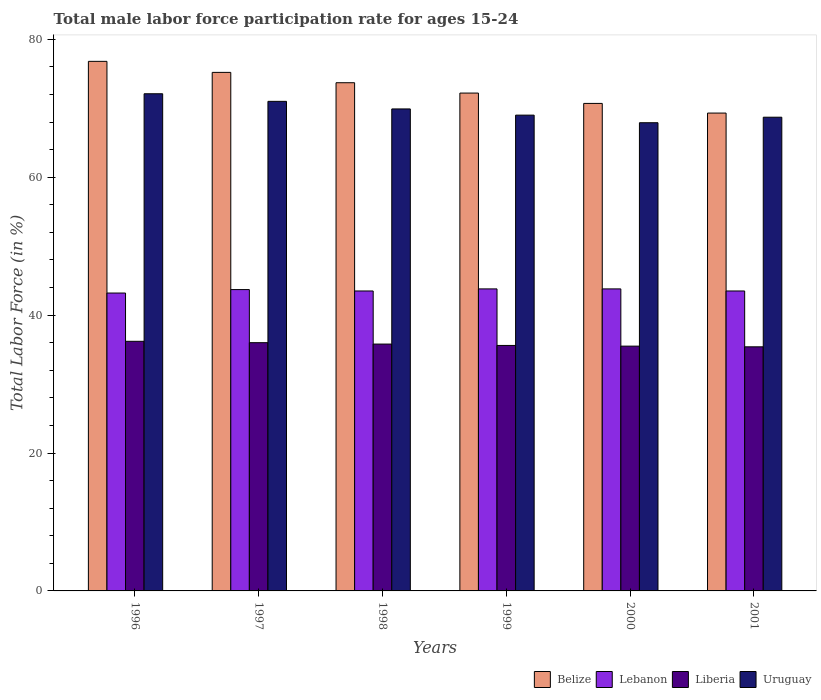How many different coloured bars are there?
Your response must be concise. 4. How many groups of bars are there?
Offer a terse response. 6. Are the number of bars per tick equal to the number of legend labels?
Make the answer very short. Yes. How many bars are there on the 4th tick from the left?
Keep it short and to the point. 4. What is the male labor force participation rate in Lebanon in 2000?
Your answer should be very brief. 43.8. Across all years, what is the maximum male labor force participation rate in Uruguay?
Your response must be concise. 72.1. Across all years, what is the minimum male labor force participation rate in Lebanon?
Give a very brief answer. 43.2. What is the total male labor force participation rate in Lebanon in the graph?
Give a very brief answer. 261.5. What is the difference between the male labor force participation rate in Belize in 1999 and that in 2001?
Ensure brevity in your answer.  2.9. What is the difference between the male labor force participation rate in Belize in 1998 and the male labor force participation rate in Uruguay in 1999?
Your answer should be very brief. 4.7. What is the average male labor force participation rate in Lebanon per year?
Make the answer very short. 43.58. In the year 2001, what is the difference between the male labor force participation rate in Lebanon and male labor force participation rate in Liberia?
Offer a very short reply. 8.1. In how many years, is the male labor force participation rate in Belize greater than 24 %?
Your response must be concise. 6. What is the difference between the highest and the second highest male labor force participation rate in Liberia?
Your answer should be compact. 0.2. In how many years, is the male labor force participation rate in Liberia greater than the average male labor force participation rate in Liberia taken over all years?
Make the answer very short. 3. What does the 3rd bar from the left in 1998 represents?
Make the answer very short. Liberia. What does the 1st bar from the right in 1997 represents?
Your response must be concise. Uruguay. Are all the bars in the graph horizontal?
Provide a succinct answer. No. Does the graph contain any zero values?
Make the answer very short. No. Where does the legend appear in the graph?
Provide a succinct answer. Bottom right. How are the legend labels stacked?
Make the answer very short. Horizontal. What is the title of the graph?
Offer a terse response. Total male labor force participation rate for ages 15-24. Does "Luxembourg" appear as one of the legend labels in the graph?
Your answer should be very brief. No. What is the label or title of the Y-axis?
Keep it short and to the point. Total Labor Force (in %). What is the Total Labor Force (in %) in Belize in 1996?
Your answer should be very brief. 76.8. What is the Total Labor Force (in %) in Lebanon in 1996?
Offer a terse response. 43.2. What is the Total Labor Force (in %) in Liberia in 1996?
Your answer should be compact. 36.2. What is the Total Labor Force (in %) in Uruguay in 1996?
Offer a very short reply. 72.1. What is the Total Labor Force (in %) of Belize in 1997?
Offer a terse response. 75.2. What is the Total Labor Force (in %) in Lebanon in 1997?
Provide a short and direct response. 43.7. What is the Total Labor Force (in %) of Uruguay in 1997?
Make the answer very short. 71. What is the Total Labor Force (in %) in Belize in 1998?
Make the answer very short. 73.7. What is the Total Labor Force (in %) of Lebanon in 1998?
Give a very brief answer. 43.5. What is the Total Labor Force (in %) of Liberia in 1998?
Make the answer very short. 35.8. What is the Total Labor Force (in %) in Uruguay in 1998?
Your answer should be very brief. 69.9. What is the Total Labor Force (in %) of Belize in 1999?
Your answer should be very brief. 72.2. What is the Total Labor Force (in %) of Lebanon in 1999?
Keep it short and to the point. 43.8. What is the Total Labor Force (in %) of Liberia in 1999?
Give a very brief answer. 35.6. What is the Total Labor Force (in %) of Belize in 2000?
Make the answer very short. 70.7. What is the Total Labor Force (in %) of Lebanon in 2000?
Provide a short and direct response. 43.8. What is the Total Labor Force (in %) of Liberia in 2000?
Provide a succinct answer. 35.5. What is the Total Labor Force (in %) in Uruguay in 2000?
Your response must be concise. 67.9. What is the Total Labor Force (in %) in Belize in 2001?
Offer a very short reply. 69.3. What is the Total Labor Force (in %) in Lebanon in 2001?
Offer a terse response. 43.5. What is the Total Labor Force (in %) of Liberia in 2001?
Your response must be concise. 35.4. What is the Total Labor Force (in %) of Uruguay in 2001?
Your answer should be compact. 68.7. Across all years, what is the maximum Total Labor Force (in %) of Belize?
Make the answer very short. 76.8. Across all years, what is the maximum Total Labor Force (in %) of Lebanon?
Your answer should be compact. 43.8. Across all years, what is the maximum Total Labor Force (in %) of Liberia?
Ensure brevity in your answer.  36.2. Across all years, what is the maximum Total Labor Force (in %) of Uruguay?
Your answer should be compact. 72.1. Across all years, what is the minimum Total Labor Force (in %) in Belize?
Offer a very short reply. 69.3. Across all years, what is the minimum Total Labor Force (in %) of Lebanon?
Ensure brevity in your answer.  43.2. Across all years, what is the minimum Total Labor Force (in %) of Liberia?
Keep it short and to the point. 35.4. Across all years, what is the minimum Total Labor Force (in %) in Uruguay?
Offer a very short reply. 67.9. What is the total Total Labor Force (in %) of Belize in the graph?
Offer a terse response. 437.9. What is the total Total Labor Force (in %) in Lebanon in the graph?
Provide a short and direct response. 261.5. What is the total Total Labor Force (in %) of Liberia in the graph?
Keep it short and to the point. 214.5. What is the total Total Labor Force (in %) of Uruguay in the graph?
Provide a succinct answer. 418.6. What is the difference between the Total Labor Force (in %) of Lebanon in 1996 and that in 1997?
Provide a succinct answer. -0.5. What is the difference between the Total Labor Force (in %) of Liberia in 1996 and that in 1997?
Keep it short and to the point. 0.2. What is the difference between the Total Labor Force (in %) in Uruguay in 1996 and that in 1998?
Offer a very short reply. 2.2. What is the difference between the Total Labor Force (in %) in Uruguay in 1996 and that in 1999?
Ensure brevity in your answer.  3.1. What is the difference between the Total Labor Force (in %) in Belize in 1996 and that in 2000?
Give a very brief answer. 6.1. What is the difference between the Total Labor Force (in %) in Lebanon in 1996 and that in 2000?
Your response must be concise. -0.6. What is the difference between the Total Labor Force (in %) in Liberia in 1996 and that in 2000?
Make the answer very short. 0.7. What is the difference between the Total Labor Force (in %) of Lebanon in 1996 and that in 2001?
Provide a short and direct response. -0.3. What is the difference between the Total Labor Force (in %) of Liberia in 1996 and that in 2001?
Your answer should be very brief. 0.8. What is the difference between the Total Labor Force (in %) in Liberia in 1997 and that in 1998?
Make the answer very short. 0.2. What is the difference between the Total Labor Force (in %) of Uruguay in 1997 and that in 1998?
Your answer should be compact. 1.1. What is the difference between the Total Labor Force (in %) of Lebanon in 1997 and that in 1999?
Give a very brief answer. -0.1. What is the difference between the Total Labor Force (in %) of Uruguay in 1997 and that in 1999?
Your answer should be compact. 2. What is the difference between the Total Labor Force (in %) of Belize in 1997 and that in 2000?
Offer a terse response. 4.5. What is the difference between the Total Labor Force (in %) in Liberia in 1997 and that in 2000?
Your response must be concise. 0.5. What is the difference between the Total Labor Force (in %) in Uruguay in 1997 and that in 2000?
Make the answer very short. 3.1. What is the difference between the Total Labor Force (in %) in Liberia in 1998 and that in 1999?
Provide a short and direct response. 0.2. What is the difference between the Total Labor Force (in %) of Uruguay in 1998 and that in 1999?
Your answer should be compact. 0.9. What is the difference between the Total Labor Force (in %) of Liberia in 1998 and that in 2000?
Your answer should be compact. 0.3. What is the difference between the Total Labor Force (in %) in Uruguay in 1998 and that in 2000?
Ensure brevity in your answer.  2. What is the difference between the Total Labor Force (in %) in Lebanon in 1998 and that in 2001?
Provide a short and direct response. 0. What is the difference between the Total Labor Force (in %) in Liberia in 1998 and that in 2001?
Provide a succinct answer. 0.4. What is the difference between the Total Labor Force (in %) in Uruguay in 1998 and that in 2001?
Provide a succinct answer. 1.2. What is the difference between the Total Labor Force (in %) in Belize in 1999 and that in 2000?
Your answer should be compact. 1.5. What is the difference between the Total Labor Force (in %) in Liberia in 1999 and that in 2000?
Your answer should be very brief. 0.1. What is the difference between the Total Labor Force (in %) of Lebanon in 1999 and that in 2001?
Make the answer very short. 0.3. What is the difference between the Total Labor Force (in %) in Liberia in 1999 and that in 2001?
Provide a short and direct response. 0.2. What is the difference between the Total Labor Force (in %) of Belize in 2000 and that in 2001?
Provide a short and direct response. 1.4. What is the difference between the Total Labor Force (in %) in Uruguay in 2000 and that in 2001?
Ensure brevity in your answer.  -0.8. What is the difference between the Total Labor Force (in %) of Belize in 1996 and the Total Labor Force (in %) of Lebanon in 1997?
Your answer should be very brief. 33.1. What is the difference between the Total Labor Force (in %) in Belize in 1996 and the Total Labor Force (in %) in Liberia in 1997?
Offer a terse response. 40.8. What is the difference between the Total Labor Force (in %) in Belize in 1996 and the Total Labor Force (in %) in Uruguay in 1997?
Provide a short and direct response. 5.8. What is the difference between the Total Labor Force (in %) of Lebanon in 1996 and the Total Labor Force (in %) of Liberia in 1997?
Provide a short and direct response. 7.2. What is the difference between the Total Labor Force (in %) of Lebanon in 1996 and the Total Labor Force (in %) of Uruguay in 1997?
Give a very brief answer. -27.8. What is the difference between the Total Labor Force (in %) of Liberia in 1996 and the Total Labor Force (in %) of Uruguay in 1997?
Provide a succinct answer. -34.8. What is the difference between the Total Labor Force (in %) of Belize in 1996 and the Total Labor Force (in %) of Lebanon in 1998?
Offer a very short reply. 33.3. What is the difference between the Total Labor Force (in %) in Belize in 1996 and the Total Labor Force (in %) in Liberia in 1998?
Keep it short and to the point. 41. What is the difference between the Total Labor Force (in %) in Belize in 1996 and the Total Labor Force (in %) in Uruguay in 1998?
Provide a succinct answer. 6.9. What is the difference between the Total Labor Force (in %) in Lebanon in 1996 and the Total Labor Force (in %) in Liberia in 1998?
Your response must be concise. 7.4. What is the difference between the Total Labor Force (in %) in Lebanon in 1996 and the Total Labor Force (in %) in Uruguay in 1998?
Your response must be concise. -26.7. What is the difference between the Total Labor Force (in %) of Liberia in 1996 and the Total Labor Force (in %) of Uruguay in 1998?
Keep it short and to the point. -33.7. What is the difference between the Total Labor Force (in %) of Belize in 1996 and the Total Labor Force (in %) of Lebanon in 1999?
Provide a succinct answer. 33. What is the difference between the Total Labor Force (in %) of Belize in 1996 and the Total Labor Force (in %) of Liberia in 1999?
Your response must be concise. 41.2. What is the difference between the Total Labor Force (in %) in Belize in 1996 and the Total Labor Force (in %) in Uruguay in 1999?
Your answer should be very brief. 7.8. What is the difference between the Total Labor Force (in %) in Lebanon in 1996 and the Total Labor Force (in %) in Uruguay in 1999?
Your response must be concise. -25.8. What is the difference between the Total Labor Force (in %) of Liberia in 1996 and the Total Labor Force (in %) of Uruguay in 1999?
Make the answer very short. -32.8. What is the difference between the Total Labor Force (in %) in Belize in 1996 and the Total Labor Force (in %) in Lebanon in 2000?
Ensure brevity in your answer.  33. What is the difference between the Total Labor Force (in %) of Belize in 1996 and the Total Labor Force (in %) of Liberia in 2000?
Keep it short and to the point. 41.3. What is the difference between the Total Labor Force (in %) of Lebanon in 1996 and the Total Labor Force (in %) of Uruguay in 2000?
Provide a short and direct response. -24.7. What is the difference between the Total Labor Force (in %) of Liberia in 1996 and the Total Labor Force (in %) of Uruguay in 2000?
Provide a succinct answer. -31.7. What is the difference between the Total Labor Force (in %) in Belize in 1996 and the Total Labor Force (in %) in Lebanon in 2001?
Provide a succinct answer. 33.3. What is the difference between the Total Labor Force (in %) in Belize in 1996 and the Total Labor Force (in %) in Liberia in 2001?
Provide a short and direct response. 41.4. What is the difference between the Total Labor Force (in %) in Lebanon in 1996 and the Total Labor Force (in %) in Uruguay in 2001?
Offer a terse response. -25.5. What is the difference between the Total Labor Force (in %) in Liberia in 1996 and the Total Labor Force (in %) in Uruguay in 2001?
Provide a succinct answer. -32.5. What is the difference between the Total Labor Force (in %) of Belize in 1997 and the Total Labor Force (in %) of Lebanon in 1998?
Ensure brevity in your answer.  31.7. What is the difference between the Total Labor Force (in %) of Belize in 1997 and the Total Labor Force (in %) of Liberia in 1998?
Make the answer very short. 39.4. What is the difference between the Total Labor Force (in %) in Lebanon in 1997 and the Total Labor Force (in %) in Uruguay in 1998?
Your answer should be very brief. -26.2. What is the difference between the Total Labor Force (in %) in Liberia in 1997 and the Total Labor Force (in %) in Uruguay in 1998?
Offer a terse response. -33.9. What is the difference between the Total Labor Force (in %) of Belize in 1997 and the Total Labor Force (in %) of Lebanon in 1999?
Make the answer very short. 31.4. What is the difference between the Total Labor Force (in %) of Belize in 1997 and the Total Labor Force (in %) of Liberia in 1999?
Offer a terse response. 39.6. What is the difference between the Total Labor Force (in %) in Belize in 1997 and the Total Labor Force (in %) in Uruguay in 1999?
Ensure brevity in your answer.  6.2. What is the difference between the Total Labor Force (in %) of Lebanon in 1997 and the Total Labor Force (in %) of Uruguay in 1999?
Provide a succinct answer. -25.3. What is the difference between the Total Labor Force (in %) of Liberia in 1997 and the Total Labor Force (in %) of Uruguay in 1999?
Provide a short and direct response. -33. What is the difference between the Total Labor Force (in %) of Belize in 1997 and the Total Labor Force (in %) of Lebanon in 2000?
Give a very brief answer. 31.4. What is the difference between the Total Labor Force (in %) in Belize in 1997 and the Total Labor Force (in %) in Liberia in 2000?
Make the answer very short. 39.7. What is the difference between the Total Labor Force (in %) in Belize in 1997 and the Total Labor Force (in %) in Uruguay in 2000?
Your response must be concise. 7.3. What is the difference between the Total Labor Force (in %) in Lebanon in 1997 and the Total Labor Force (in %) in Uruguay in 2000?
Ensure brevity in your answer.  -24.2. What is the difference between the Total Labor Force (in %) in Liberia in 1997 and the Total Labor Force (in %) in Uruguay in 2000?
Provide a succinct answer. -31.9. What is the difference between the Total Labor Force (in %) in Belize in 1997 and the Total Labor Force (in %) in Lebanon in 2001?
Provide a succinct answer. 31.7. What is the difference between the Total Labor Force (in %) in Belize in 1997 and the Total Labor Force (in %) in Liberia in 2001?
Provide a succinct answer. 39.8. What is the difference between the Total Labor Force (in %) in Belize in 1997 and the Total Labor Force (in %) in Uruguay in 2001?
Give a very brief answer. 6.5. What is the difference between the Total Labor Force (in %) in Lebanon in 1997 and the Total Labor Force (in %) in Liberia in 2001?
Your answer should be compact. 8.3. What is the difference between the Total Labor Force (in %) in Lebanon in 1997 and the Total Labor Force (in %) in Uruguay in 2001?
Keep it short and to the point. -25. What is the difference between the Total Labor Force (in %) in Liberia in 1997 and the Total Labor Force (in %) in Uruguay in 2001?
Offer a terse response. -32.7. What is the difference between the Total Labor Force (in %) in Belize in 1998 and the Total Labor Force (in %) in Lebanon in 1999?
Ensure brevity in your answer.  29.9. What is the difference between the Total Labor Force (in %) in Belize in 1998 and the Total Labor Force (in %) in Liberia in 1999?
Make the answer very short. 38.1. What is the difference between the Total Labor Force (in %) in Lebanon in 1998 and the Total Labor Force (in %) in Uruguay in 1999?
Give a very brief answer. -25.5. What is the difference between the Total Labor Force (in %) of Liberia in 1998 and the Total Labor Force (in %) of Uruguay in 1999?
Your response must be concise. -33.2. What is the difference between the Total Labor Force (in %) in Belize in 1998 and the Total Labor Force (in %) in Lebanon in 2000?
Give a very brief answer. 29.9. What is the difference between the Total Labor Force (in %) of Belize in 1998 and the Total Labor Force (in %) of Liberia in 2000?
Make the answer very short. 38.2. What is the difference between the Total Labor Force (in %) of Lebanon in 1998 and the Total Labor Force (in %) of Liberia in 2000?
Ensure brevity in your answer.  8. What is the difference between the Total Labor Force (in %) in Lebanon in 1998 and the Total Labor Force (in %) in Uruguay in 2000?
Provide a succinct answer. -24.4. What is the difference between the Total Labor Force (in %) in Liberia in 1998 and the Total Labor Force (in %) in Uruguay in 2000?
Your answer should be compact. -32.1. What is the difference between the Total Labor Force (in %) of Belize in 1998 and the Total Labor Force (in %) of Lebanon in 2001?
Your answer should be very brief. 30.2. What is the difference between the Total Labor Force (in %) in Belize in 1998 and the Total Labor Force (in %) in Liberia in 2001?
Offer a very short reply. 38.3. What is the difference between the Total Labor Force (in %) in Lebanon in 1998 and the Total Labor Force (in %) in Uruguay in 2001?
Provide a short and direct response. -25.2. What is the difference between the Total Labor Force (in %) in Liberia in 1998 and the Total Labor Force (in %) in Uruguay in 2001?
Offer a very short reply. -32.9. What is the difference between the Total Labor Force (in %) of Belize in 1999 and the Total Labor Force (in %) of Lebanon in 2000?
Ensure brevity in your answer.  28.4. What is the difference between the Total Labor Force (in %) of Belize in 1999 and the Total Labor Force (in %) of Liberia in 2000?
Give a very brief answer. 36.7. What is the difference between the Total Labor Force (in %) in Belize in 1999 and the Total Labor Force (in %) in Uruguay in 2000?
Your response must be concise. 4.3. What is the difference between the Total Labor Force (in %) of Lebanon in 1999 and the Total Labor Force (in %) of Uruguay in 2000?
Offer a very short reply. -24.1. What is the difference between the Total Labor Force (in %) of Liberia in 1999 and the Total Labor Force (in %) of Uruguay in 2000?
Make the answer very short. -32.3. What is the difference between the Total Labor Force (in %) of Belize in 1999 and the Total Labor Force (in %) of Lebanon in 2001?
Ensure brevity in your answer.  28.7. What is the difference between the Total Labor Force (in %) in Belize in 1999 and the Total Labor Force (in %) in Liberia in 2001?
Provide a succinct answer. 36.8. What is the difference between the Total Labor Force (in %) in Belize in 1999 and the Total Labor Force (in %) in Uruguay in 2001?
Ensure brevity in your answer.  3.5. What is the difference between the Total Labor Force (in %) of Lebanon in 1999 and the Total Labor Force (in %) of Liberia in 2001?
Offer a terse response. 8.4. What is the difference between the Total Labor Force (in %) of Lebanon in 1999 and the Total Labor Force (in %) of Uruguay in 2001?
Provide a succinct answer. -24.9. What is the difference between the Total Labor Force (in %) of Liberia in 1999 and the Total Labor Force (in %) of Uruguay in 2001?
Provide a short and direct response. -33.1. What is the difference between the Total Labor Force (in %) in Belize in 2000 and the Total Labor Force (in %) in Lebanon in 2001?
Give a very brief answer. 27.2. What is the difference between the Total Labor Force (in %) of Belize in 2000 and the Total Labor Force (in %) of Liberia in 2001?
Your answer should be compact. 35.3. What is the difference between the Total Labor Force (in %) of Belize in 2000 and the Total Labor Force (in %) of Uruguay in 2001?
Your response must be concise. 2. What is the difference between the Total Labor Force (in %) of Lebanon in 2000 and the Total Labor Force (in %) of Liberia in 2001?
Your answer should be very brief. 8.4. What is the difference between the Total Labor Force (in %) of Lebanon in 2000 and the Total Labor Force (in %) of Uruguay in 2001?
Keep it short and to the point. -24.9. What is the difference between the Total Labor Force (in %) of Liberia in 2000 and the Total Labor Force (in %) of Uruguay in 2001?
Offer a very short reply. -33.2. What is the average Total Labor Force (in %) of Belize per year?
Your response must be concise. 72.98. What is the average Total Labor Force (in %) of Lebanon per year?
Give a very brief answer. 43.58. What is the average Total Labor Force (in %) of Liberia per year?
Your response must be concise. 35.75. What is the average Total Labor Force (in %) of Uruguay per year?
Your response must be concise. 69.77. In the year 1996, what is the difference between the Total Labor Force (in %) of Belize and Total Labor Force (in %) of Lebanon?
Offer a very short reply. 33.6. In the year 1996, what is the difference between the Total Labor Force (in %) in Belize and Total Labor Force (in %) in Liberia?
Make the answer very short. 40.6. In the year 1996, what is the difference between the Total Labor Force (in %) of Belize and Total Labor Force (in %) of Uruguay?
Your answer should be compact. 4.7. In the year 1996, what is the difference between the Total Labor Force (in %) of Lebanon and Total Labor Force (in %) of Uruguay?
Offer a very short reply. -28.9. In the year 1996, what is the difference between the Total Labor Force (in %) in Liberia and Total Labor Force (in %) in Uruguay?
Make the answer very short. -35.9. In the year 1997, what is the difference between the Total Labor Force (in %) of Belize and Total Labor Force (in %) of Lebanon?
Provide a short and direct response. 31.5. In the year 1997, what is the difference between the Total Labor Force (in %) of Belize and Total Labor Force (in %) of Liberia?
Offer a very short reply. 39.2. In the year 1997, what is the difference between the Total Labor Force (in %) in Lebanon and Total Labor Force (in %) in Liberia?
Make the answer very short. 7.7. In the year 1997, what is the difference between the Total Labor Force (in %) of Lebanon and Total Labor Force (in %) of Uruguay?
Your response must be concise. -27.3. In the year 1997, what is the difference between the Total Labor Force (in %) in Liberia and Total Labor Force (in %) in Uruguay?
Give a very brief answer. -35. In the year 1998, what is the difference between the Total Labor Force (in %) of Belize and Total Labor Force (in %) of Lebanon?
Your response must be concise. 30.2. In the year 1998, what is the difference between the Total Labor Force (in %) in Belize and Total Labor Force (in %) in Liberia?
Give a very brief answer. 37.9. In the year 1998, what is the difference between the Total Labor Force (in %) in Lebanon and Total Labor Force (in %) in Liberia?
Your answer should be very brief. 7.7. In the year 1998, what is the difference between the Total Labor Force (in %) of Lebanon and Total Labor Force (in %) of Uruguay?
Keep it short and to the point. -26.4. In the year 1998, what is the difference between the Total Labor Force (in %) in Liberia and Total Labor Force (in %) in Uruguay?
Offer a very short reply. -34.1. In the year 1999, what is the difference between the Total Labor Force (in %) in Belize and Total Labor Force (in %) in Lebanon?
Your answer should be compact. 28.4. In the year 1999, what is the difference between the Total Labor Force (in %) in Belize and Total Labor Force (in %) in Liberia?
Your answer should be compact. 36.6. In the year 1999, what is the difference between the Total Labor Force (in %) of Belize and Total Labor Force (in %) of Uruguay?
Your answer should be very brief. 3.2. In the year 1999, what is the difference between the Total Labor Force (in %) in Lebanon and Total Labor Force (in %) in Liberia?
Your answer should be compact. 8.2. In the year 1999, what is the difference between the Total Labor Force (in %) of Lebanon and Total Labor Force (in %) of Uruguay?
Offer a terse response. -25.2. In the year 1999, what is the difference between the Total Labor Force (in %) of Liberia and Total Labor Force (in %) of Uruguay?
Your answer should be very brief. -33.4. In the year 2000, what is the difference between the Total Labor Force (in %) of Belize and Total Labor Force (in %) of Lebanon?
Your answer should be very brief. 26.9. In the year 2000, what is the difference between the Total Labor Force (in %) of Belize and Total Labor Force (in %) of Liberia?
Keep it short and to the point. 35.2. In the year 2000, what is the difference between the Total Labor Force (in %) in Lebanon and Total Labor Force (in %) in Uruguay?
Offer a very short reply. -24.1. In the year 2000, what is the difference between the Total Labor Force (in %) in Liberia and Total Labor Force (in %) in Uruguay?
Provide a short and direct response. -32.4. In the year 2001, what is the difference between the Total Labor Force (in %) in Belize and Total Labor Force (in %) in Lebanon?
Offer a terse response. 25.8. In the year 2001, what is the difference between the Total Labor Force (in %) in Belize and Total Labor Force (in %) in Liberia?
Your response must be concise. 33.9. In the year 2001, what is the difference between the Total Labor Force (in %) of Lebanon and Total Labor Force (in %) of Uruguay?
Your response must be concise. -25.2. In the year 2001, what is the difference between the Total Labor Force (in %) in Liberia and Total Labor Force (in %) in Uruguay?
Make the answer very short. -33.3. What is the ratio of the Total Labor Force (in %) in Belize in 1996 to that in 1997?
Offer a very short reply. 1.02. What is the ratio of the Total Labor Force (in %) of Lebanon in 1996 to that in 1997?
Ensure brevity in your answer.  0.99. What is the ratio of the Total Labor Force (in %) of Liberia in 1996 to that in 1997?
Your answer should be compact. 1.01. What is the ratio of the Total Labor Force (in %) in Uruguay in 1996 to that in 1997?
Ensure brevity in your answer.  1.02. What is the ratio of the Total Labor Force (in %) of Belize in 1996 to that in 1998?
Give a very brief answer. 1.04. What is the ratio of the Total Labor Force (in %) of Liberia in 1996 to that in 1998?
Provide a succinct answer. 1.01. What is the ratio of the Total Labor Force (in %) of Uruguay in 1996 to that in 1998?
Provide a short and direct response. 1.03. What is the ratio of the Total Labor Force (in %) in Belize in 1996 to that in 1999?
Offer a terse response. 1.06. What is the ratio of the Total Labor Force (in %) of Lebanon in 1996 to that in 1999?
Keep it short and to the point. 0.99. What is the ratio of the Total Labor Force (in %) of Liberia in 1996 to that in 1999?
Offer a terse response. 1.02. What is the ratio of the Total Labor Force (in %) in Uruguay in 1996 to that in 1999?
Give a very brief answer. 1.04. What is the ratio of the Total Labor Force (in %) in Belize in 1996 to that in 2000?
Your answer should be very brief. 1.09. What is the ratio of the Total Labor Force (in %) of Lebanon in 1996 to that in 2000?
Your response must be concise. 0.99. What is the ratio of the Total Labor Force (in %) in Liberia in 1996 to that in 2000?
Your answer should be very brief. 1.02. What is the ratio of the Total Labor Force (in %) in Uruguay in 1996 to that in 2000?
Your response must be concise. 1.06. What is the ratio of the Total Labor Force (in %) of Belize in 1996 to that in 2001?
Ensure brevity in your answer.  1.11. What is the ratio of the Total Labor Force (in %) of Liberia in 1996 to that in 2001?
Keep it short and to the point. 1.02. What is the ratio of the Total Labor Force (in %) in Uruguay in 1996 to that in 2001?
Your answer should be compact. 1.05. What is the ratio of the Total Labor Force (in %) of Belize in 1997 to that in 1998?
Ensure brevity in your answer.  1.02. What is the ratio of the Total Labor Force (in %) in Lebanon in 1997 to that in 1998?
Provide a succinct answer. 1. What is the ratio of the Total Labor Force (in %) of Liberia in 1997 to that in 1998?
Your answer should be very brief. 1.01. What is the ratio of the Total Labor Force (in %) in Uruguay in 1997 to that in 1998?
Give a very brief answer. 1.02. What is the ratio of the Total Labor Force (in %) of Belize in 1997 to that in 1999?
Offer a terse response. 1.04. What is the ratio of the Total Labor Force (in %) in Liberia in 1997 to that in 1999?
Your answer should be compact. 1.01. What is the ratio of the Total Labor Force (in %) in Uruguay in 1997 to that in 1999?
Offer a very short reply. 1.03. What is the ratio of the Total Labor Force (in %) in Belize in 1997 to that in 2000?
Keep it short and to the point. 1.06. What is the ratio of the Total Labor Force (in %) of Liberia in 1997 to that in 2000?
Your answer should be compact. 1.01. What is the ratio of the Total Labor Force (in %) in Uruguay in 1997 to that in 2000?
Provide a short and direct response. 1.05. What is the ratio of the Total Labor Force (in %) of Belize in 1997 to that in 2001?
Make the answer very short. 1.09. What is the ratio of the Total Labor Force (in %) in Liberia in 1997 to that in 2001?
Your response must be concise. 1.02. What is the ratio of the Total Labor Force (in %) in Uruguay in 1997 to that in 2001?
Your response must be concise. 1.03. What is the ratio of the Total Labor Force (in %) of Belize in 1998 to that in 1999?
Offer a terse response. 1.02. What is the ratio of the Total Labor Force (in %) of Liberia in 1998 to that in 1999?
Your response must be concise. 1.01. What is the ratio of the Total Labor Force (in %) in Uruguay in 1998 to that in 1999?
Provide a succinct answer. 1.01. What is the ratio of the Total Labor Force (in %) in Belize in 1998 to that in 2000?
Offer a terse response. 1.04. What is the ratio of the Total Labor Force (in %) of Liberia in 1998 to that in 2000?
Offer a very short reply. 1.01. What is the ratio of the Total Labor Force (in %) in Uruguay in 1998 to that in 2000?
Give a very brief answer. 1.03. What is the ratio of the Total Labor Force (in %) of Belize in 1998 to that in 2001?
Give a very brief answer. 1.06. What is the ratio of the Total Labor Force (in %) of Lebanon in 1998 to that in 2001?
Keep it short and to the point. 1. What is the ratio of the Total Labor Force (in %) of Liberia in 1998 to that in 2001?
Your response must be concise. 1.01. What is the ratio of the Total Labor Force (in %) in Uruguay in 1998 to that in 2001?
Provide a succinct answer. 1.02. What is the ratio of the Total Labor Force (in %) of Belize in 1999 to that in 2000?
Give a very brief answer. 1.02. What is the ratio of the Total Labor Force (in %) in Liberia in 1999 to that in 2000?
Make the answer very short. 1. What is the ratio of the Total Labor Force (in %) in Uruguay in 1999 to that in 2000?
Provide a succinct answer. 1.02. What is the ratio of the Total Labor Force (in %) of Belize in 1999 to that in 2001?
Provide a short and direct response. 1.04. What is the ratio of the Total Labor Force (in %) in Lebanon in 1999 to that in 2001?
Give a very brief answer. 1.01. What is the ratio of the Total Labor Force (in %) of Liberia in 1999 to that in 2001?
Give a very brief answer. 1.01. What is the ratio of the Total Labor Force (in %) of Uruguay in 1999 to that in 2001?
Ensure brevity in your answer.  1. What is the ratio of the Total Labor Force (in %) of Belize in 2000 to that in 2001?
Provide a succinct answer. 1.02. What is the ratio of the Total Labor Force (in %) in Liberia in 2000 to that in 2001?
Keep it short and to the point. 1. What is the ratio of the Total Labor Force (in %) in Uruguay in 2000 to that in 2001?
Your response must be concise. 0.99. What is the difference between the highest and the second highest Total Labor Force (in %) of Belize?
Keep it short and to the point. 1.6. What is the difference between the highest and the second highest Total Labor Force (in %) of Uruguay?
Your answer should be compact. 1.1. What is the difference between the highest and the lowest Total Labor Force (in %) of Belize?
Give a very brief answer. 7.5. 